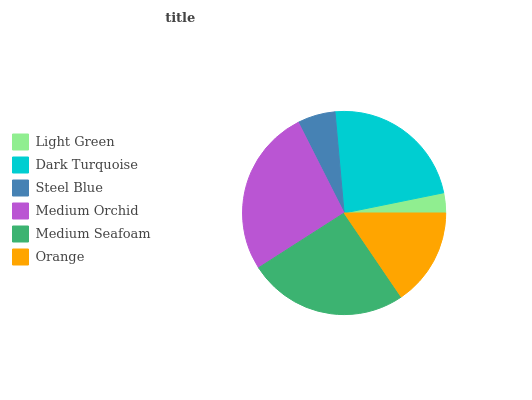Is Light Green the minimum?
Answer yes or no. Yes. Is Medium Orchid the maximum?
Answer yes or no. Yes. Is Dark Turquoise the minimum?
Answer yes or no. No. Is Dark Turquoise the maximum?
Answer yes or no. No. Is Dark Turquoise greater than Light Green?
Answer yes or no. Yes. Is Light Green less than Dark Turquoise?
Answer yes or no. Yes. Is Light Green greater than Dark Turquoise?
Answer yes or no. No. Is Dark Turquoise less than Light Green?
Answer yes or no. No. Is Dark Turquoise the high median?
Answer yes or no. Yes. Is Orange the low median?
Answer yes or no. Yes. Is Medium Orchid the high median?
Answer yes or no. No. Is Medium Orchid the low median?
Answer yes or no. No. 